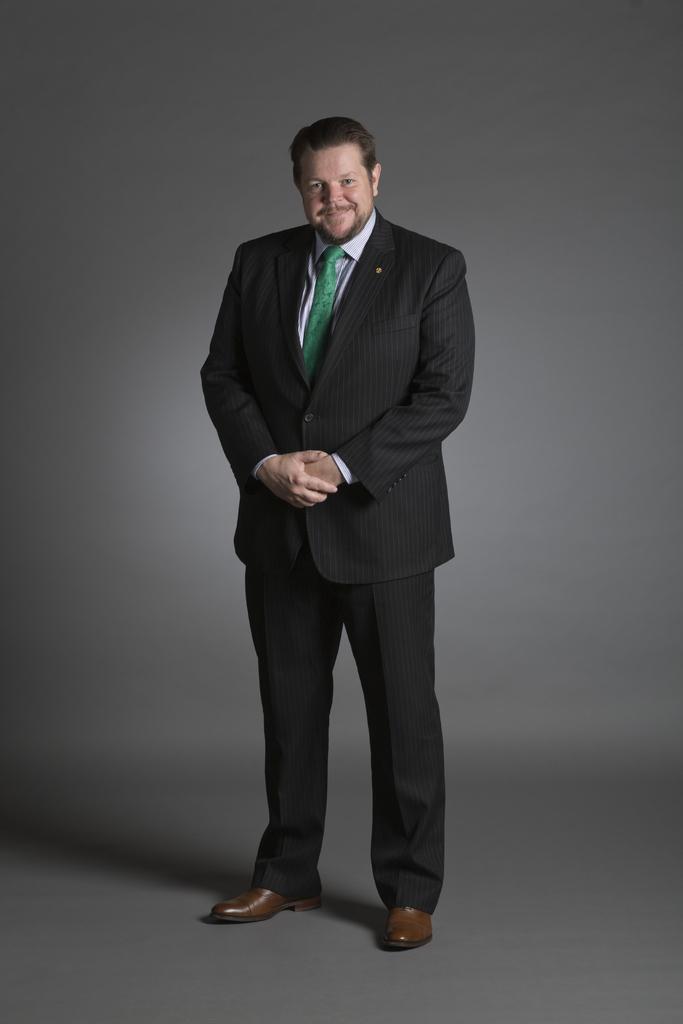Please provide a concise description of this image. In the center of the image there is a man standing on the ground. 